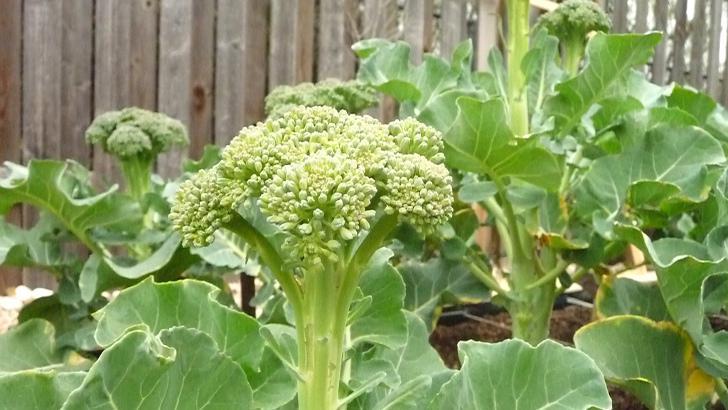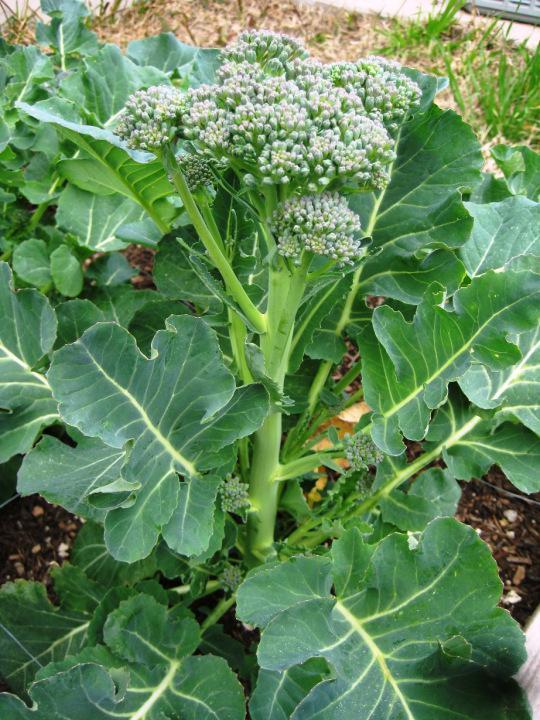The first image is the image on the left, the second image is the image on the right. Given the left and right images, does the statement "The left and right image contains the same number of growing broccoli with at least one flowering." hold true? Answer yes or no. Yes. The first image is the image on the left, the second image is the image on the right. For the images displayed, is the sentence "The plants are entirely green." factually correct? Answer yes or no. No. 